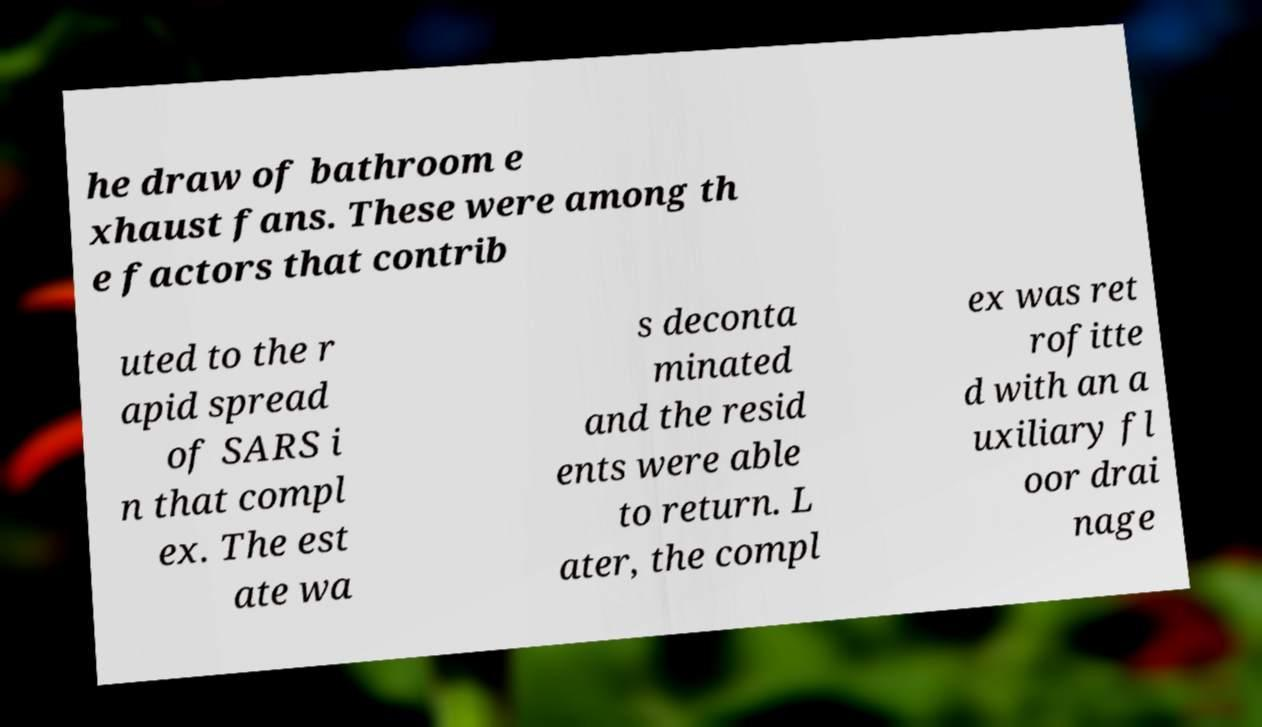Could you assist in decoding the text presented in this image and type it out clearly? he draw of bathroom e xhaust fans. These were among th e factors that contrib uted to the r apid spread of SARS i n that compl ex. The est ate wa s deconta minated and the resid ents were able to return. L ater, the compl ex was ret rofitte d with an a uxiliary fl oor drai nage 